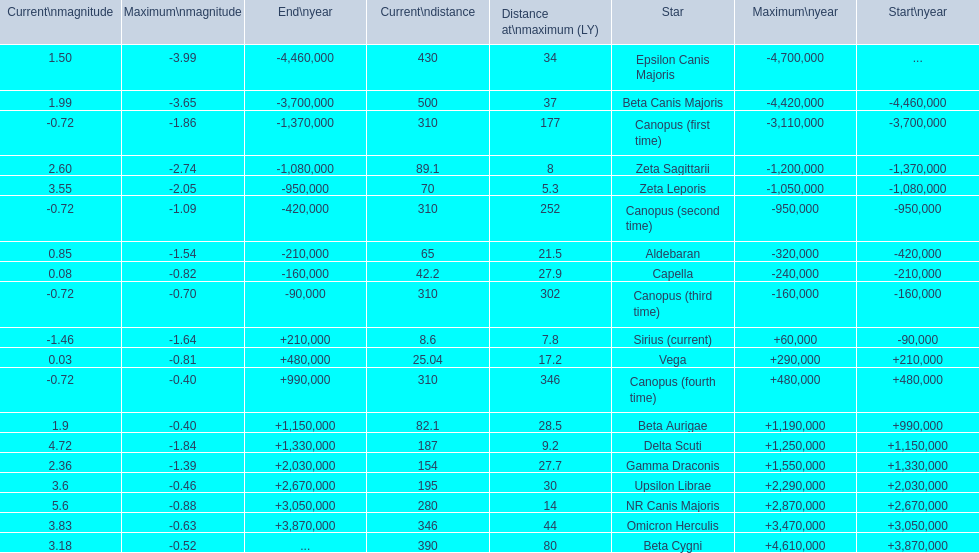What are the historical brightest stars? Epsilon Canis Majoris, Beta Canis Majoris, Canopus (first time), Zeta Sagittarii, Zeta Leporis, Canopus (second time), Aldebaran, Capella, Canopus (third time), Sirius (current), Vega, Canopus (fourth time), Beta Aurigae, Delta Scuti, Gamma Draconis, Upsilon Librae, NR Canis Majoris, Omicron Herculis, Beta Cygni. Of those which star has a distance at maximum of 80 Beta Cygni. 